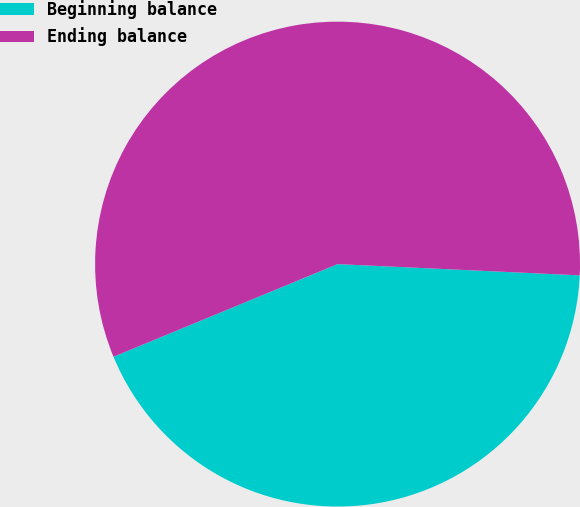Convert chart to OTSL. <chart><loc_0><loc_0><loc_500><loc_500><pie_chart><fcel>Beginning balance<fcel>Ending balance<nl><fcel>43.02%<fcel>56.98%<nl></chart> 